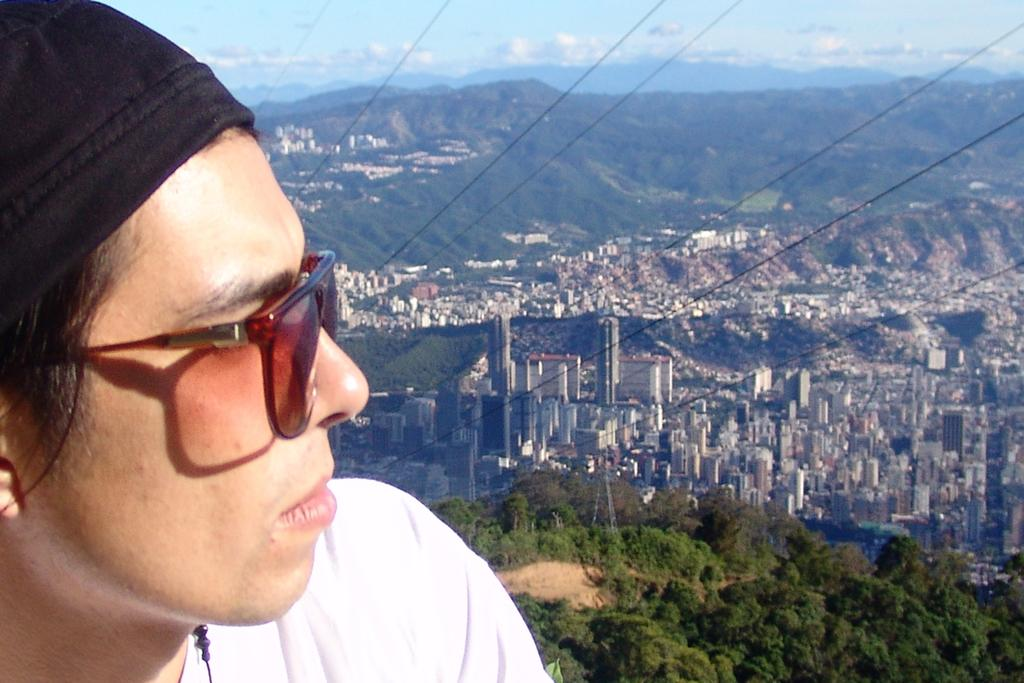What can be seen on the person in the image? The person in the image is wearing spectacles. What type of natural environment is visible in the image? There are trees and hills in the image. What type of man-made structures are present in the image? There are buildings in the image. What else can be seen in the image besides the person, trees, buildings, and hills? There are cables in the image. What part of the natural environment is visible in the image? The sky is visible in the image. What type of plantation can be seen in the image? There is no plantation present in the image. What instrument is the person playing in the image? There is no instrument visible in the image. 